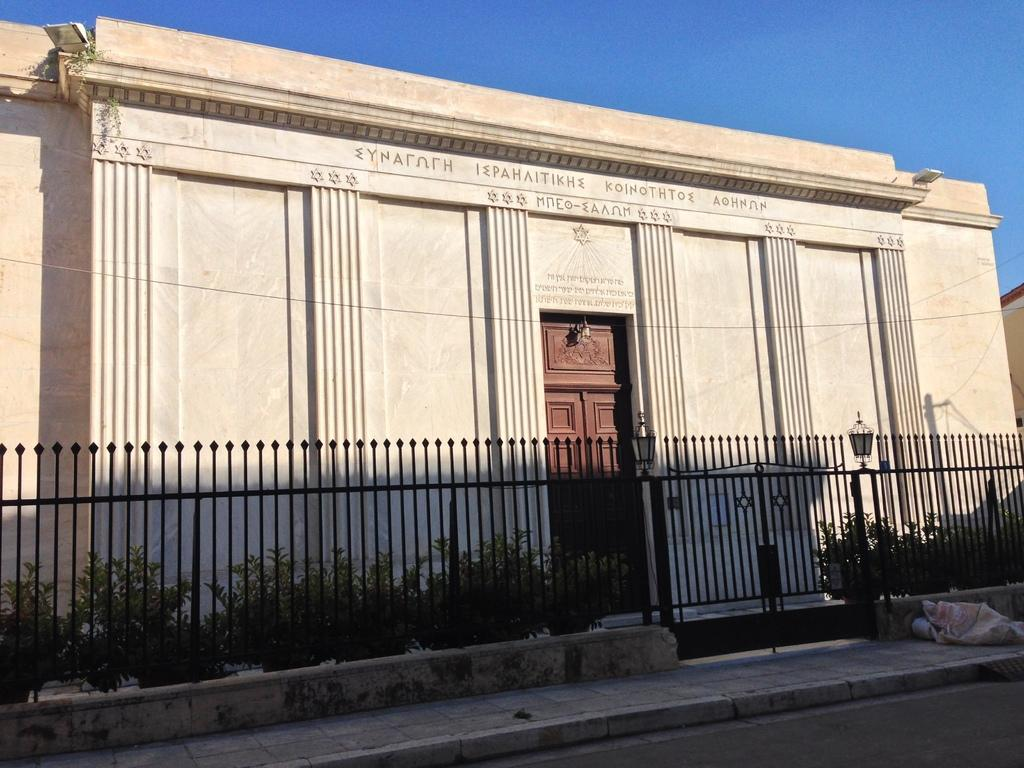What type of structure is present in the image? There is a building in the picture. What surrounds the building? There is a fence around the building. What can be seen in the image besides the building and fence? There are plants visible in the image. What type of shoe is the uncle wearing in the image? There is no shoe or uncle present in the image; it only features a building, a fence, and plants. 